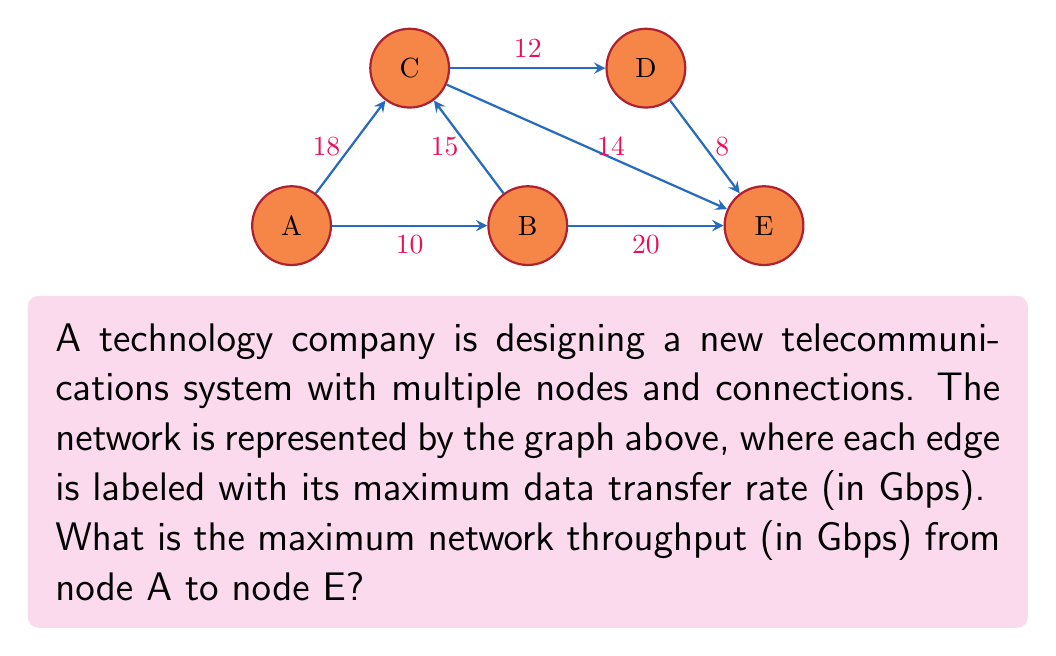Help me with this question. To solve this problem, we need to find the maximum flow from node A to node E. We can use the Ford-Fulkerson algorithm or its improvement, the Edmonds-Karp algorithm. Here's a step-by-step solution:

1) First, identify all possible paths from A to E:
   Path 1: A -> B -> E
   Path 2: A -> C -> E
   Path 3: A -> C -> D -> E
   Path 4: A -> B -> C -> E
   Path 5: A -> B -> C -> D -> E

2) Start with zero flow and iteratively increase the flow along augmenting paths:

   Iteration 1: Choose A -> C -> E (18 + 14 = 32 Gbps)
   Flow: 14 Gbps (limited by C -> E)

   Iteration 2: Choose A -> B -> E (10 + 20 = 30 Gbps)
   Additional flow: 10 Gbps (limited by A -> B)

   Iteration 3: Choose A -> C -> D -> E
   Remaining capacity: A -> C: 4 Gbps, C -> D: 12 Gbps, D -> E: 8 Gbps
   Additional flow: 4 Gbps (limited by A -> C)

   Iteration 4: Choose A -> B -> C -> D -> E
   Remaining capacity: B -> C: 15 Gbps, C -> D: 8 Gbps, D -> E: 4 Gbps
   Additional flow: 4 Gbps (limited by D -> E)

3) No more augmenting paths exist. The maximum flow is the sum of all additional flows:

   $$\text{Max Flow} = 14 + 10 + 4 + 4 = 32 \text{ Gbps}$$

Therefore, the maximum network throughput from A to E is 32 Gbps.
Answer: 32 Gbps 